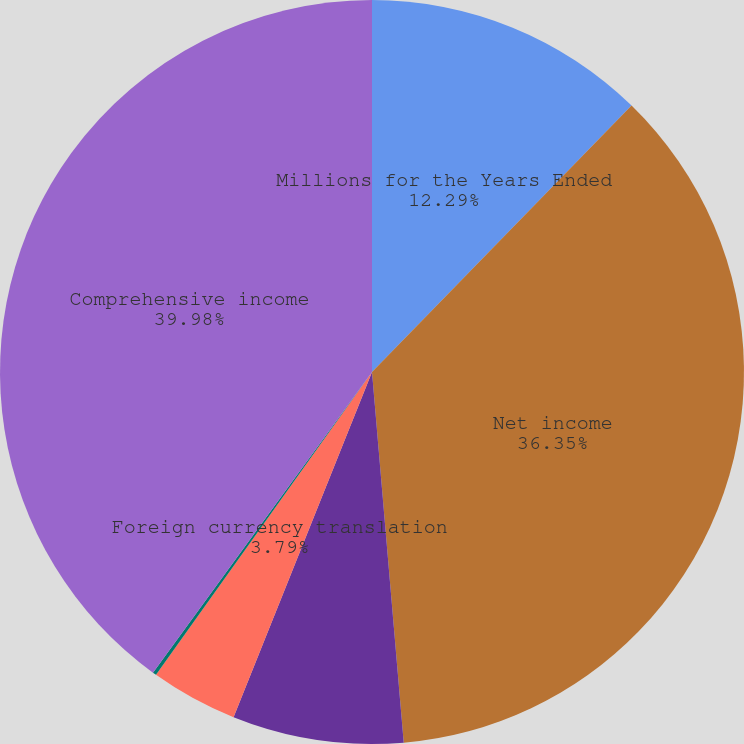<chart> <loc_0><loc_0><loc_500><loc_500><pie_chart><fcel>Millions for the Years Ended<fcel>Net income<fcel>Defined benefit plans<fcel>Foreign currency translation<fcel>Total other comprehensive<fcel>Comprehensive income<nl><fcel>12.29%<fcel>36.35%<fcel>7.43%<fcel>3.79%<fcel>0.16%<fcel>39.98%<nl></chart> 